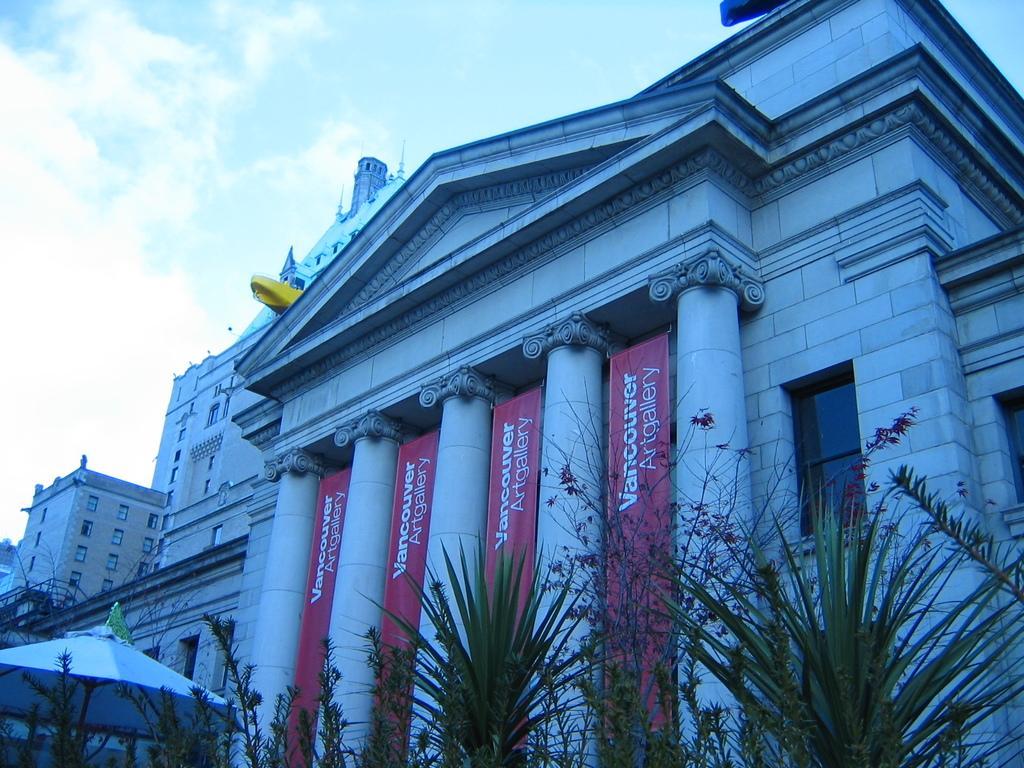How would you summarize this image in a sentence or two? In this image we can see buildings, pillars, banners, plants, flag, and an umbrella. In the background there is sky with clouds. 